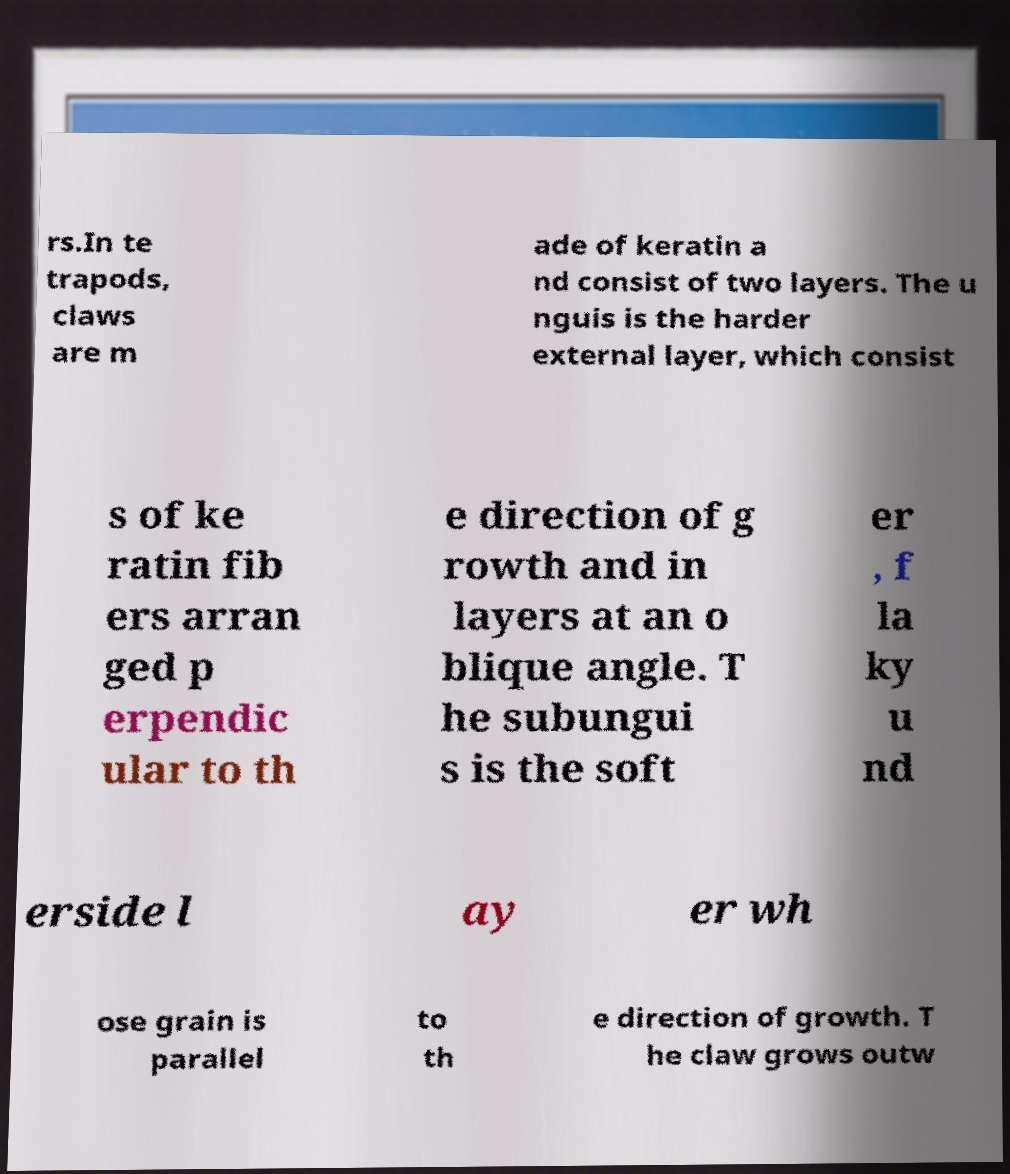There's text embedded in this image that I need extracted. Can you transcribe it verbatim? rs.In te trapods, claws are m ade of keratin a nd consist of two layers. The u nguis is the harder external layer, which consist s of ke ratin fib ers arran ged p erpendic ular to th e direction of g rowth and in layers at an o blique angle. T he subungui s is the soft er , f la ky u nd erside l ay er wh ose grain is parallel to th e direction of growth. T he claw grows outw 